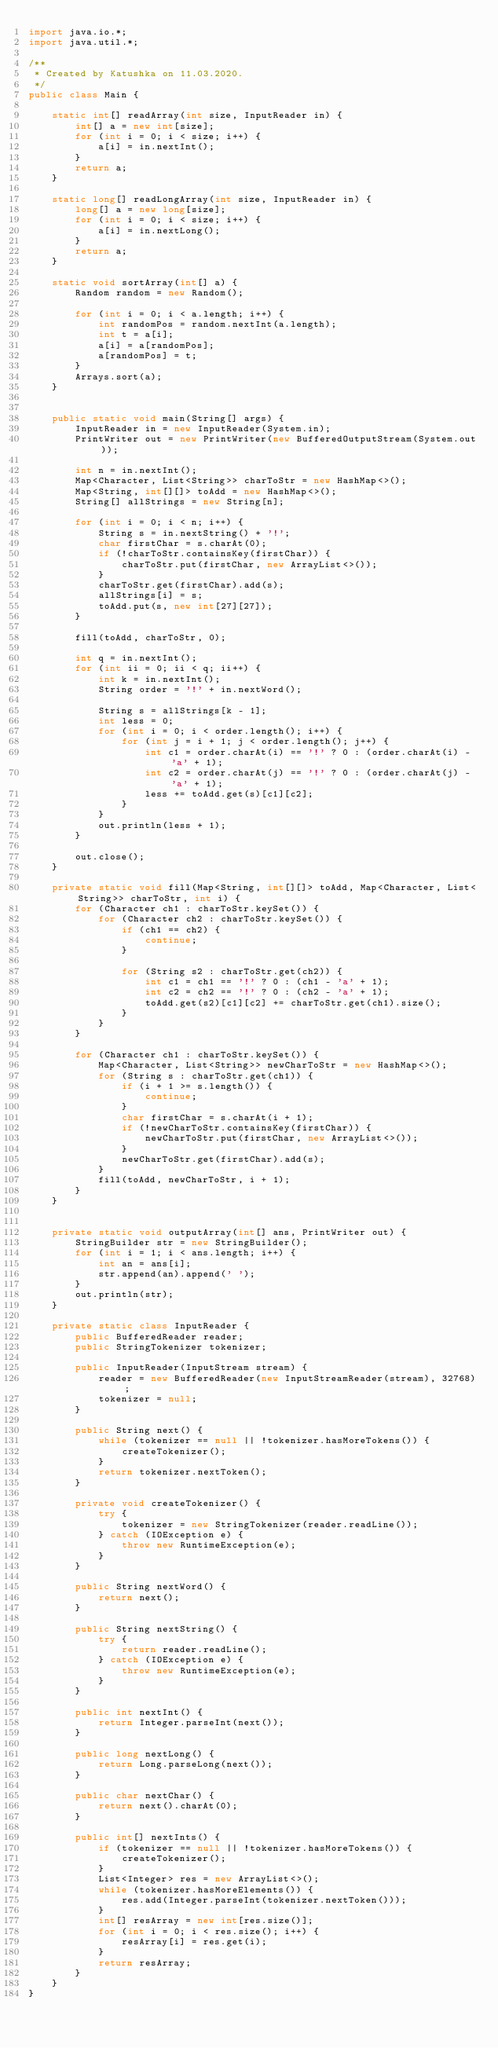<code> <loc_0><loc_0><loc_500><loc_500><_Java_>import java.io.*;
import java.util.*;

/**
 * Created by Katushka on 11.03.2020.
 */
public class Main {

    static int[] readArray(int size, InputReader in) {
        int[] a = new int[size];
        for (int i = 0; i < size; i++) {
            a[i] = in.nextInt();
        }
        return a;
    }

    static long[] readLongArray(int size, InputReader in) {
        long[] a = new long[size];
        for (int i = 0; i < size; i++) {
            a[i] = in.nextLong();
        }
        return a;
    }

    static void sortArray(int[] a) {
        Random random = new Random();

        for (int i = 0; i < a.length; i++) {
            int randomPos = random.nextInt(a.length);
            int t = a[i];
            a[i] = a[randomPos];
            a[randomPos] = t;
        }
        Arrays.sort(a);
    }


    public static void main(String[] args) {
        InputReader in = new InputReader(System.in);
        PrintWriter out = new PrintWriter(new BufferedOutputStream(System.out));

        int n = in.nextInt();
        Map<Character, List<String>> charToStr = new HashMap<>();
        Map<String, int[][]> toAdd = new HashMap<>();
        String[] allStrings = new String[n];

        for (int i = 0; i < n; i++) {
            String s = in.nextString() + '!';
            char firstChar = s.charAt(0);
            if (!charToStr.containsKey(firstChar)) {
                charToStr.put(firstChar, new ArrayList<>());
            }
            charToStr.get(firstChar).add(s);
            allStrings[i] = s;
            toAdd.put(s, new int[27][27]);
        }

        fill(toAdd, charToStr, 0);

        int q = in.nextInt();
        for (int ii = 0; ii < q; ii++) {
            int k = in.nextInt();
            String order = '!' + in.nextWord();

            String s = allStrings[k - 1];
            int less = 0;
            for (int i = 0; i < order.length(); i++) {
                for (int j = i + 1; j < order.length(); j++) {
                    int c1 = order.charAt(i) == '!' ? 0 : (order.charAt(i) - 'a' + 1);
                    int c2 = order.charAt(j) == '!' ? 0 : (order.charAt(j) - 'a' + 1);
                    less += toAdd.get(s)[c1][c2];
                }
            }
            out.println(less + 1);
        }

        out.close();
    }

    private static void fill(Map<String, int[][]> toAdd, Map<Character, List<String>> charToStr, int i) {
        for (Character ch1 : charToStr.keySet()) {
            for (Character ch2 : charToStr.keySet()) {
                if (ch1 == ch2) {
                    continue;
                }

                for (String s2 : charToStr.get(ch2)) {
                    int c1 = ch1 == '!' ? 0 : (ch1 - 'a' + 1);
                    int c2 = ch2 == '!' ? 0 : (ch2 - 'a' + 1);
                    toAdd.get(s2)[c1][c2] += charToStr.get(ch1).size();
                }
            }
        }

        for (Character ch1 : charToStr.keySet()) {
            Map<Character, List<String>> newCharToStr = new HashMap<>();
            for (String s : charToStr.get(ch1)) {
                if (i + 1 >= s.length()) {
                    continue;
                }
                char firstChar = s.charAt(i + 1);
                if (!newCharToStr.containsKey(firstChar)) {
                    newCharToStr.put(firstChar, new ArrayList<>());
                }
                newCharToStr.get(firstChar).add(s);
            }
            fill(toAdd, newCharToStr, i + 1);
        }
    }


    private static void outputArray(int[] ans, PrintWriter out) {
        StringBuilder str = new StringBuilder();
        for (int i = 1; i < ans.length; i++) {
            int an = ans[i];
            str.append(an).append(' ');
        }
        out.println(str);
    }

    private static class InputReader {
        public BufferedReader reader;
        public StringTokenizer tokenizer;

        public InputReader(InputStream stream) {
            reader = new BufferedReader(new InputStreamReader(stream), 32768);
            tokenizer = null;
        }

        public String next() {
            while (tokenizer == null || !tokenizer.hasMoreTokens()) {
                createTokenizer();
            }
            return tokenizer.nextToken();
        }

        private void createTokenizer() {
            try {
                tokenizer = new StringTokenizer(reader.readLine());
            } catch (IOException e) {
                throw new RuntimeException(e);
            }
        }

        public String nextWord() {
            return next();
        }

        public String nextString() {
            try {
                return reader.readLine();
            } catch (IOException e) {
                throw new RuntimeException(e);
            }
        }

        public int nextInt() {
            return Integer.parseInt(next());
        }

        public long nextLong() {
            return Long.parseLong(next());
        }

        public char nextChar() {
            return next().charAt(0);
        }

        public int[] nextInts() {
            if (tokenizer == null || !tokenizer.hasMoreTokens()) {
                createTokenizer();
            }
            List<Integer> res = new ArrayList<>();
            while (tokenizer.hasMoreElements()) {
                res.add(Integer.parseInt(tokenizer.nextToken()));
            }
            int[] resArray = new int[res.size()];
            for (int i = 0; i < res.size(); i++) {
                resArray[i] = res.get(i);
            }
            return resArray;
        }
    }
}</code> 